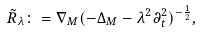Convert formula to latex. <formula><loc_0><loc_0><loc_500><loc_500>\tilde { R } _ { \lambda } \colon = \nabla _ { M } ( - \Delta _ { M } - \lambda ^ { 2 } \partial _ { t } ^ { 2 } ) ^ { - \frac { 1 } { 2 } } , \</formula> 